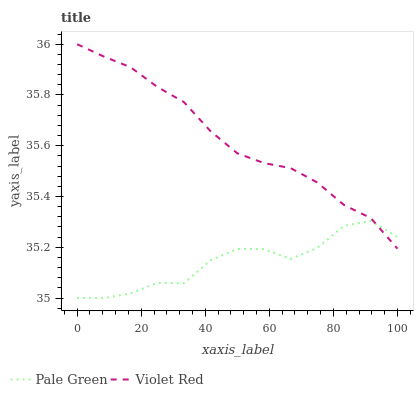Does Pale Green have the minimum area under the curve?
Answer yes or no. Yes. Does Violet Red have the maximum area under the curve?
Answer yes or no. Yes. Does Pale Green have the maximum area under the curve?
Answer yes or no. No. Is Violet Red the smoothest?
Answer yes or no. Yes. Is Pale Green the roughest?
Answer yes or no. Yes. Is Pale Green the smoothest?
Answer yes or no. No. Does Pale Green have the lowest value?
Answer yes or no. Yes. Does Violet Red have the highest value?
Answer yes or no. Yes. Does Pale Green have the highest value?
Answer yes or no. No. Does Violet Red intersect Pale Green?
Answer yes or no. Yes. Is Violet Red less than Pale Green?
Answer yes or no. No. Is Violet Red greater than Pale Green?
Answer yes or no. No. 